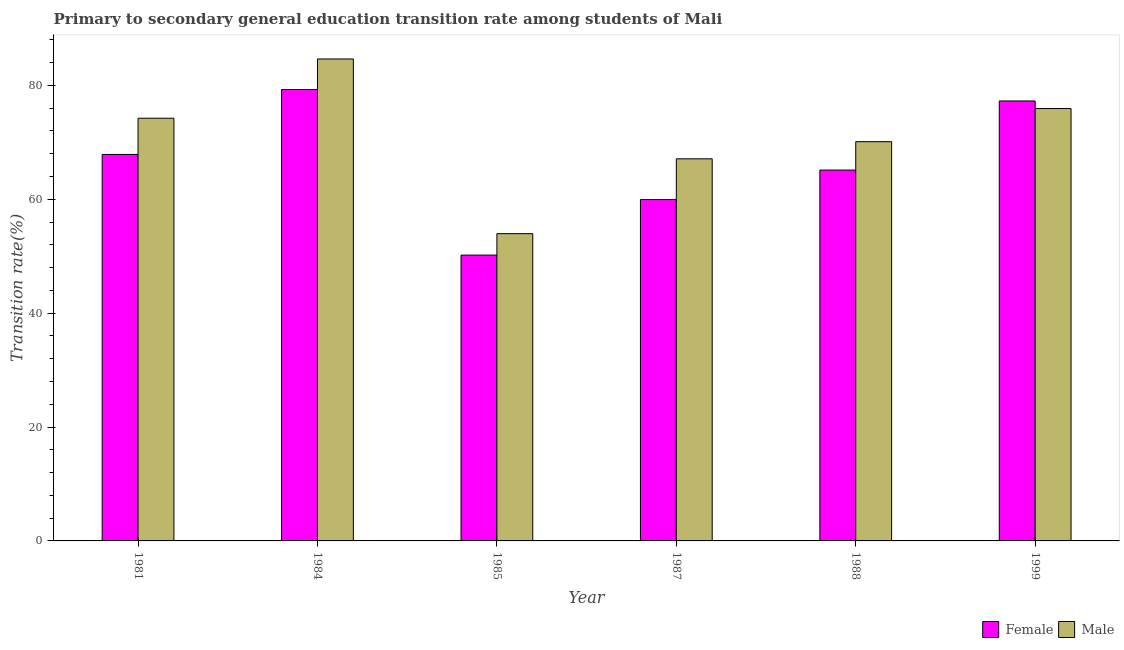Are the number of bars per tick equal to the number of legend labels?
Your answer should be very brief. Yes. How many bars are there on the 4th tick from the left?
Your response must be concise. 2. What is the label of the 5th group of bars from the left?
Offer a very short reply. 1988. In how many cases, is the number of bars for a given year not equal to the number of legend labels?
Make the answer very short. 0. What is the transition rate among female students in 1985?
Offer a terse response. 50.2. Across all years, what is the maximum transition rate among female students?
Provide a succinct answer. 79.27. Across all years, what is the minimum transition rate among male students?
Keep it short and to the point. 53.96. In which year was the transition rate among female students minimum?
Ensure brevity in your answer.  1985. What is the total transition rate among male students in the graph?
Your answer should be compact. 425.99. What is the difference between the transition rate among female students in 1984 and that in 1988?
Give a very brief answer. 14.14. What is the difference between the transition rate among female students in 1981 and the transition rate among male students in 1987?
Ensure brevity in your answer.  7.93. What is the average transition rate among female students per year?
Offer a terse response. 66.61. What is the ratio of the transition rate among female students in 1988 to that in 1999?
Ensure brevity in your answer.  0.84. What is the difference between the highest and the second highest transition rate among male students?
Your answer should be very brief. 8.7. What is the difference between the highest and the lowest transition rate among female students?
Provide a succinct answer. 29.08. What does the 2nd bar from the left in 1981 represents?
Keep it short and to the point. Male. How many bars are there?
Ensure brevity in your answer.  12. Are all the bars in the graph horizontal?
Your response must be concise. No. How many years are there in the graph?
Keep it short and to the point. 6. Does the graph contain any zero values?
Provide a short and direct response. No. Does the graph contain grids?
Offer a terse response. No. What is the title of the graph?
Provide a succinct answer. Primary to secondary general education transition rate among students of Mali. Does "Under-5(female)" appear as one of the legend labels in the graph?
Your answer should be compact. No. What is the label or title of the X-axis?
Give a very brief answer. Year. What is the label or title of the Y-axis?
Your answer should be very brief. Transition rate(%). What is the Transition rate(%) of Female in 1981?
Offer a terse response. 67.88. What is the Transition rate(%) of Male in 1981?
Your answer should be compact. 74.23. What is the Transition rate(%) in Female in 1984?
Make the answer very short. 79.27. What is the Transition rate(%) in Male in 1984?
Keep it short and to the point. 84.64. What is the Transition rate(%) in Female in 1985?
Provide a succinct answer. 50.2. What is the Transition rate(%) in Male in 1985?
Make the answer very short. 53.96. What is the Transition rate(%) in Female in 1987?
Offer a terse response. 59.95. What is the Transition rate(%) in Male in 1987?
Your response must be concise. 67.11. What is the Transition rate(%) of Female in 1988?
Your response must be concise. 65.13. What is the Transition rate(%) of Male in 1988?
Provide a short and direct response. 70.12. What is the Transition rate(%) in Female in 1999?
Your answer should be compact. 77.26. What is the Transition rate(%) of Male in 1999?
Provide a short and direct response. 75.94. Across all years, what is the maximum Transition rate(%) in Female?
Your response must be concise. 79.27. Across all years, what is the maximum Transition rate(%) in Male?
Make the answer very short. 84.64. Across all years, what is the minimum Transition rate(%) in Female?
Give a very brief answer. 50.2. Across all years, what is the minimum Transition rate(%) of Male?
Offer a very short reply. 53.96. What is the total Transition rate(%) of Female in the graph?
Your answer should be compact. 399.68. What is the total Transition rate(%) in Male in the graph?
Your answer should be very brief. 425.99. What is the difference between the Transition rate(%) in Female in 1981 and that in 1984?
Provide a succinct answer. -11.4. What is the difference between the Transition rate(%) in Male in 1981 and that in 1984?
Provide a short and direct response. -10.41. What is the difference between the Transition rate(%) of Female in 1981 and that in 1985?
Make the answer very short. 17.68. What is the difference between the Transition rate(%) in Male in 1981 and that in 1985?
Provide a succinct answer. 20.27. What is the difference between the Transition rate(%) of Female in 1981 and that in 1987?
Make the answer very short. 7.93. What is the difference between the Transition rate(%) of Male in 1981 and that in 1987?
Your response must be concise. 7.12. What is the difference between the Transition rate(%) in Female in 1981 and that in 1988?
Make the answer very short. 2.75. What is the difference between the Transition rate(%) in Male in 1981 and that in 1988?
Keep it short and to the point. 4.12. What is the difference between the Transition rate(%) in Female in 1981 and that in 1999?
Make the answer very short. -9.39. What is the difference between the Transition rate(%) in Male in 1981 and that in 1999?
Ensure brevity in your answer.  -1.71. What is the difference between the Transition rate(%) of Female in 1984 and that in 1985?
Keep it short and to the point. 29.08. What is the difference between the Transition rate(%) of Male in 1984 and that in 1985?
Ensure brevity in your answer.  30.68. What is the difference between the Transition rate(%) of Female in 1984 and that in 1987?
Give a very brief answer. 19.33. What is the difference between the Transition rate(%) in Male in 1984 and that in 1987?
Offer a very short reply. 17.53. What is the difference between the Transition rate(%) of Female in 1984 and that in 1988?
Keep it short and to the point. 14.14. What is the difference between the Transition rate(%) of Male in 1984 and that in 1988?
Make the answer very short. 14.52. What is the difference between the Transition rate(%) of Female in 1984 and that in 1999?
Make the answer very short. 2.01. What is the difference between the Transition rate(%) in Male in 1984 and that in 1999?
Keep it short and to the point. 8.7. What is the difference between the Transition rate(%) of Female in 1985 and that in 1987?
Offer a terse response. -9.75. What is the difference between the Transition rate(%) of Male in 1985 and that in 1987?
Provide a succinct answer. -13.14. What is the difference between the Transition rate(%) of Female in 1985 and that in 1988?
Offer a very short reply. -14.93. What is the difference between the Transition rate(%) of Male in 1985 and that in 1988?
Ensure brevity in your answer.  -16.15. What is the difference between the Transition rate(%) in Female in 1985 and that in 1999?
Offer a very short reply. -27.07. What is the difference between the Transition rate(%) of Male in 1985 and that in 1999?
Give a very brief answer. -21.97. What is the difference between the Transition rate(%) in Female in 1987 and that in 1988?
Provide a succinct answer. -5.18. What is the difference between the Transition rate(%) of Male in 1987 and that in 1988?
Provide a succinct answer. -3.01. What is the difference between the Transition rate(%) of Female in 1987 and that in 1999?
Make the answer very short. -17.32. What is the difference between the Transition rate(%) in Male in 1987 and that in 1999?
Give a very brief answer. -8.83. What is the difference between the Transition rate(%) of Female in 1988 and that in 1999?
Give a very brief answer. -12.14. What is the difference between the Transition rate(%) in Male in 1988 and that in 1999?
Provide a succinct answer. -5.82. What is the difference between the Transition rate(%) of Female in 1981 and the Transition rate(%) of Male in 1984?
Keep it short and to the point. -16.76. What is the difference between the Transition rate(%) of Female in 1981 and the Transition rate(%) of Male in 1985?
Your response must be concise. 13.91. What is the difference between the Transition rate(%) of Female in 1981 and the Transition rate(%) of Male in 1987?
Offer a very short reply. 0.77. What is the difference between the Transition rate(%) in Female in 1981 and the Transition rate(%) in Male in 1988?
Your answer should be very brief. -2.24. What is the difference between the Transition rate(%) of Female in 1981 and the Transition rate(%) of Male in 1999?
Ensure brevity in your answer.  -8.06. What is the difference between the Transition rate(%) of Female in 1984 and the Transition rate(%) of Male in 1985?
Give a very brief answer. 25.31. What is the difference between the Transition rate(%) of Female in 1984 and the Transition rate(%) of Male in 1987?
Your answer should be very brief. 12.17. What is the difference between the Transition rate(%) of Female in 1984 and the Transition rate(%) of Male in 1988?
Your response must be concise. 9.16. What is the difference between the Transition rate(%) of Female in 1984 and the Transition rate(%) of Male in 1999?
Keep it short and to the point. 3.34. What is the difference between the Transition rate(%) in Female in 1985 and the Transition rate(%) in Male in 1987?
Ensure brevity in your answer.  -16.91. What is the difference between the Transition rate(%) in Female in 1985 and the Transition rate(%) in Male in 1988?
Provide a succinct answer. -19.92. What is the difference between the Transition rate(%) of Female in 1985 and the Transition rate(%) of Male in 1999?
Offer a very short reply. -25.74. What is the difference between the Transition rate(%) in Female in 1987 and the Transition rate(%) in Male in 1988?
Provide a succinct answer. -10.17. What is the difference between the Transition rate(%) in Female in 1987 and the Transition rate(%) in Male in 1999?
Keep it short and to the point. -15.99. What is the difference between the Transition rate(%) of Female in 1988 and the Transition rate(%) of Male in 1999?
Keep it short and to the point. -10.81. What is the average Transition rate(%) in Female per year?
Your answer should be compact. 66.61. What is the average Transition rate(%) of Male per year?
Provide a short and direct response. 71. In the year 1981, what is the difference between the Transition rate(%) in Female and Transition rate(%) in Male?
Provide a succinct answer. -6.35. In the year 1984, what is the difference between the Transition rate(%) of Female and Transition rate(%) of Male?
Your answer should be very brief. -5.37. In the year 1985, what is the difference between the Transition rate(%) in Female and Transition rate(%) in Male?
Offer a very short reply. -3.77. In the year 1987, what is the difference between the Transition rate(%) in Female and Transition rate(%) in Male?
Make the answer very short. -7.16. In the year 1988, what is the difference between the Transition rate(%) in Female and Transition rate(%) in Male?
Keep it short and to the point. -4.99. In the year 1999, what is the difference between the Transition rate(%) of Female and Transition rate(%) of Male?
Your response must be concise. 1.33. What is the ratio of the Transition rate(%) of Female in 1981 to that in 1984?
Make the answer very short. 0.86. What is the ratio of the Transition rate(%) in Male in 1981 to that in 1984?
Keep it short and to the point. 0.88. What is the ratio of the Transition rate(%) in Female in 1981 to that in 1985?
Your answer should be compact. 1.35. What is the ratio of the Transition rate(%) in Male in 1981 to that in 1985?
Give a very brief answer. 1.38. What is the ratio of the Transition rate(%) of Female in 1981 to that in 1987?
Provide a short and direct response. 1.13. What is the ratio of the Transition rate(%) of Male in 1981 to that in 1987?
Keep it short and to the point. 1.11. What is the ratio of the Transition rate(%) in Female in 1981 to that in 1988?
Your answer should be compact. 1.04. What is the ratio of the Transition rate(%) of Male in 1981 to that in 1988?
Your answer should be compact. 1.06. What is the ratio of the Transition rate(%) of Female in 1981 to that in 1999?
Provide a short and direct response. 0.88. What is the ratio of the Transition rate(%) in Male in 1981 to that in 1999?
Your answer should be compact. 0.98. What is the ratio of the Transition rate(%) of Female in 1984 to that in 1985?
Offer a terse response. 1.58. What is the ratio of the Transition rate(%) of Male in 1984 to that in 1985?
Offer a terse response. 1.57. What is the ratio of the Transition rate(%) in Female in 1984 to that in 1987?
Your answer should be compact. 1.32. What is the ratio of the Transition rate(%) in Male in 1984 to that in 1987?
Your answer should be compact. 1.26. What is the ratio of the Transition rate(%) of Female in 1984 to that in 1988?
Make the answer very short. 1.22. What is the ratio of the Transition rate(%) in Male in 1984 to that in 1988?
Offer a very short reply. 1.21. What is the ratio of the Transition rate(%) of Male in 1984 to that in 1999?
Your answer should be compact. 1.11. What is the ratio of the Transition rate(%) of Female in 1985 to that in 1987?
Keep it short and to the point. 0.84. What is the ratio of the Transition rate(%) in Male in 1985 to that in 1987?
Ensure brevity in your answer.  0.8. What is the ratio of the Transition rate(%) in Female in 1985 to that in 1988?
Your answer should be compact. 0.77. What is the ratio of the Transition rate(%) in Male in 1985 to that in 1988?
Provide a short and direct response. 0.77. What is the ratio of the Transition rate(%) of Female in 1985 to that in 1999?
Provide a succinct answer. 0.65. What is the ratio of the Transition rate(%) in Male in 1985 to that in 1999?
Provide a succinct answer. 0.71. What is the ratio of the Transition rate(%) in Female in 1987 to that in 1988?
Your response must be concise. 0.92. What is the ratio of the Transition rate(%) of Male in 1987 to that in 1988?
Provide a succinct answer. 0.96. What is the ratio of the Transition rate(%) of Female in 1987 to that in 1999?
Your answer should be very brief. 0.78. What is the ratio of the Transition rate(%) of Male in 1987 to that in 1999?
Offer a very short reply. 0.88. What is the ratio of the Transition rate(%) of Female in 1988 to that in 1999?
Give a very brief answer. 0.84. What is the ratio of the Transition rate(%) in Male in 1988 to that in 1999?
Offer a terse response. 0.92. What is the difference between the highest and the second highest Transition rate(%) in Female?
Offer a very short reply. 2.01. What is the difference between the highest and the second highest Transition rate(%) in Male?
Give a very brief answer. 8.7. What is the difference between the highest and the lowest Transition rate(%) in Female?
Your answer should be compact. 29.08. What is the difference between the highest and the lowest Transition rate(%) in Male?
Provide a succinct answer. 30.68. 